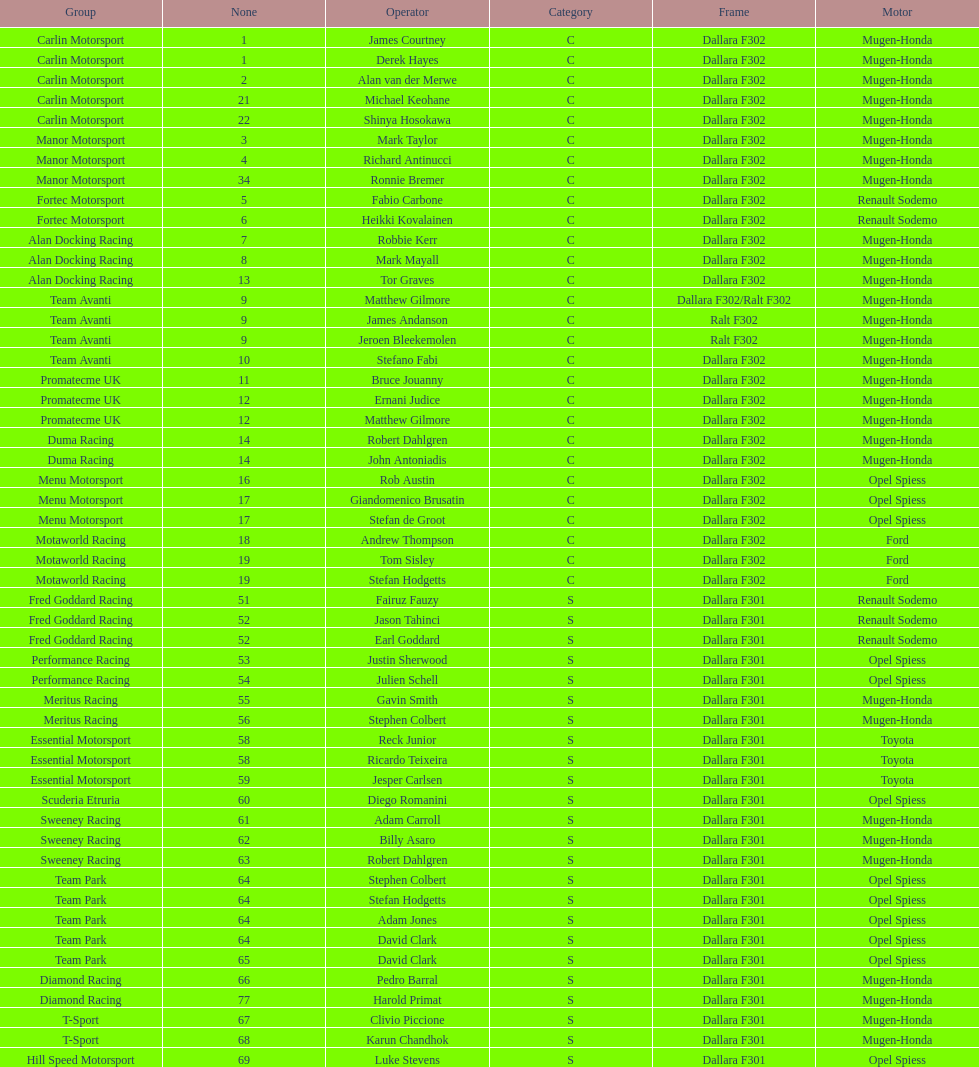What is the number of teams that had drivers all from the same country? 4. 